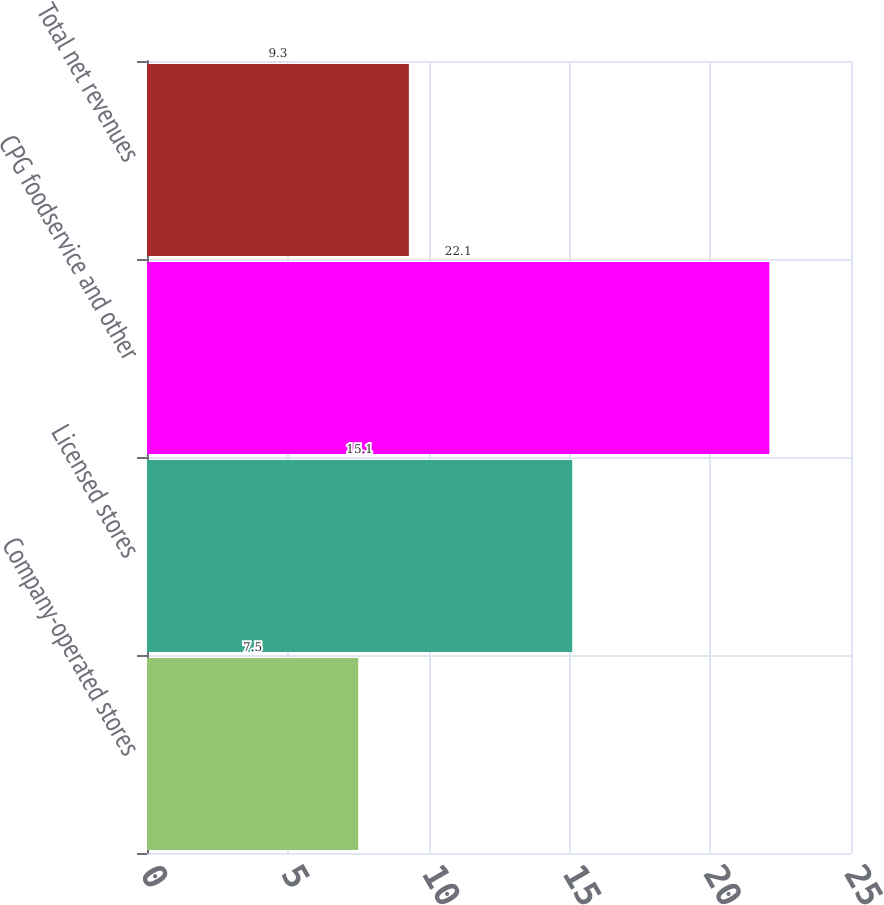Convert chart to OTSL. <chart><loc_0><loc_0><loc_500><loc_500><bar_chart><fcel>Company-operated stores<fcel>Licensed stores<fcel>CPG foodservice and other<fcel>Total net revenues<nl><fcel>7.5<fcel>15.1<fcel>22.1<fcel>9.3<nl></chart> 